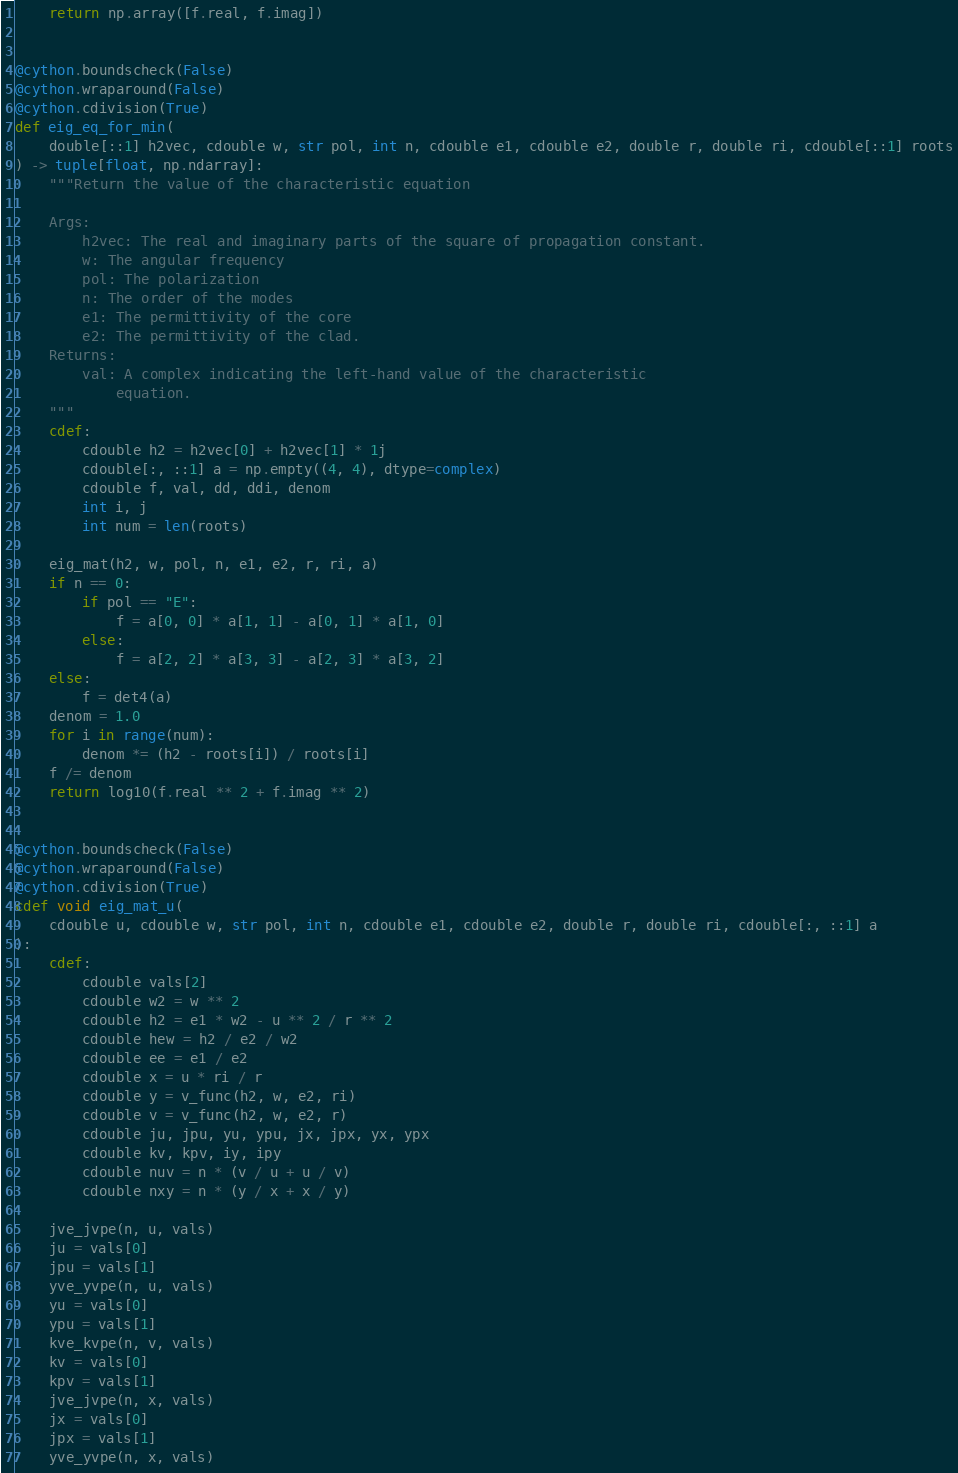<code> <loc_0><loc_0><loc_500><loc_500><_Cython_>    return np.array([f.real, f.imag])


@cython.boundscheck(False)
@cython.wraparound(False)
@cython.cdivision(True)
def eig_eq_for_min(
    double[::1] h2vec, cdouble w, str pol, int n, cdouble e1, cdouble e2, double r, double ri, cdouble[::1] roots
) -> tuple[float, np.ndarray]:
    """Return the value of the characteristic equation

    Args:
        h2vec: The real and imaginary parts of the square of propagation constant.
        w: The angular frequency
        pol: The polarization
        n: The order of the modes
        e1: The permittivity of the core
        e2: The permittivity of the clad.
    Returns:
        val: A complex indicating the left-hand value of the characteristic
            equation.
    """
    cdef:
        cdouble h2 = h2vec[0] + h2vec[1] * 1j
        cdouble[:, ::1] a = np.empty((4, 4), dtype=complex)
        cdouble f, val, dd, ddi, denom
        int i, j
        int num = len(roots)

    eig_mat(h2, w, pol, n, e1, e2, r, ri, a)
    if n == 0:
        if pol == "E":
            f = a[0, 0] * a[1, 1] - a[0, 1] * a[1, 0]
        else:
            f = a[2, 2] * a[3, 3] - a[2, 3] * a[3, 2]
    else:
        f = det4(a)
    denom = 1.0
    for i in range(num):
        denom *= (h2 - roots[i]) / roots[i]
    f /= denom
    return log10(f.real ** 2 + f.imag ** 2)


@cython.boundscheck(False)
@cython.wraparound(False)
@cython.cdivision(True)
cdef void eig_mat_u(
    cdouble u, cdouble w, str pol, int n, cdouble e1, cdouble e2, double r, double ri, cdouble[:, ::1] a
):
    cdef:
        cdouble vals[2]
        cdouble w2 = w ** 2
        cdouble h2 = e1 * w2 - u ** 2 / r ** 2
        cdouble hew = h2 / e2 / w2
        cdouble ee = e1 / e2
        cdouble x = u * ri / r
        cdouble y = v_func(h2, w, e2, ri)
        cdouble v = v_func(h2, w, e2, r)
        cdouble ju, jpu, yu, ypu, jx, jpx, yx, ypx
        cdouble kv, kpv, iy, ipy
        cdouble nuv = n * (v / u + u / v)
        cdouble nxy = n * (y / x + x / y)

    jve_jvpe(n, u, vals)
    ju = vals[0]
    jpu = vals[1]
    yve_yvpe(n, u, vals)
    yu = vals[0]
    ypu = vals[1]
    kve_kvpe(n, v, vals)
    kv = vals[0]
    kpv = vals[1]
    jve_jvpe(n, x, vals)
    jx = vals[0]
    jpx = vals[1]
    yve_yvpe(n, x, vals)</code> 